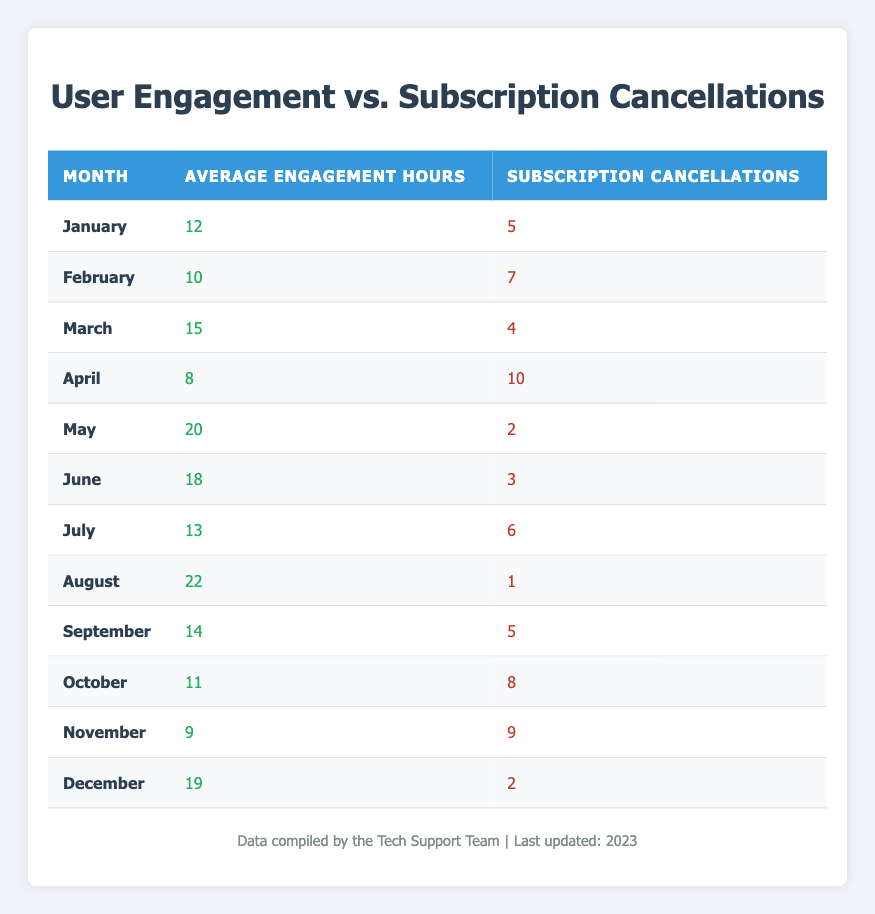What is the average engagement hours in May? In the table, under the month of May, the average engagement hours listed are 20. Therefore, the average engagement hours in May is directly taken from the table.
Answer: 20 What is the total number of subscription cancellations in the months of June and July? To find the total cancellations in June and July, we look at the respective rows: June has 3 cancellations, and July has 6 cancellations. We add these together: 3 + 6 = 9.
Answer: 9 Is it true that the highest number of subscription cancellations occurred in April? By examining the table, the number of cancellations in April is 10. We would compare that number to other months to confirm. The highest cancellations are indeed in April when checking all values listed.
Answer: Yes What was the average engagement hours across the months of the year? To find the average, we need to sum all the engagement hours: 12 + 10 + 15 + 8 + 20 + 18 + 13 + 22 + 14 + 11 + 9 + 19 =  20, so we divide this sum (  20) by the number of months (12):  20 / 12 = 15.25, the average is 15.25.
Answer: 15.25 In which month did the least amount of subscription cancellations occur? We need to examine the cancellations for each month to identify the lowest number. The month with the lowest cancellations is August with only 1 cancellation.
Answer: August 